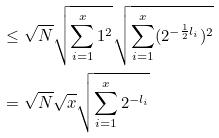Convert formula to latex. <formula><loc_0><loc_0><loc_500><loc_500>& \leq \sqrt { N } \sqrt { \sum _ { i = 1 } ^ { x } 1 ^ { 2 } } \sqrt { \sum _ { i = 1 } ^ { x } ( 2 ^ { - \frac { 1 } { 2 } l _ { i } } ) ^ { 2 } } \\ & = \sqrt { N } \sqrt { x } \sqrt { \sum _ { i = 1 } ^ { x } 2 ^ { - l _ { i } } }</formula> 